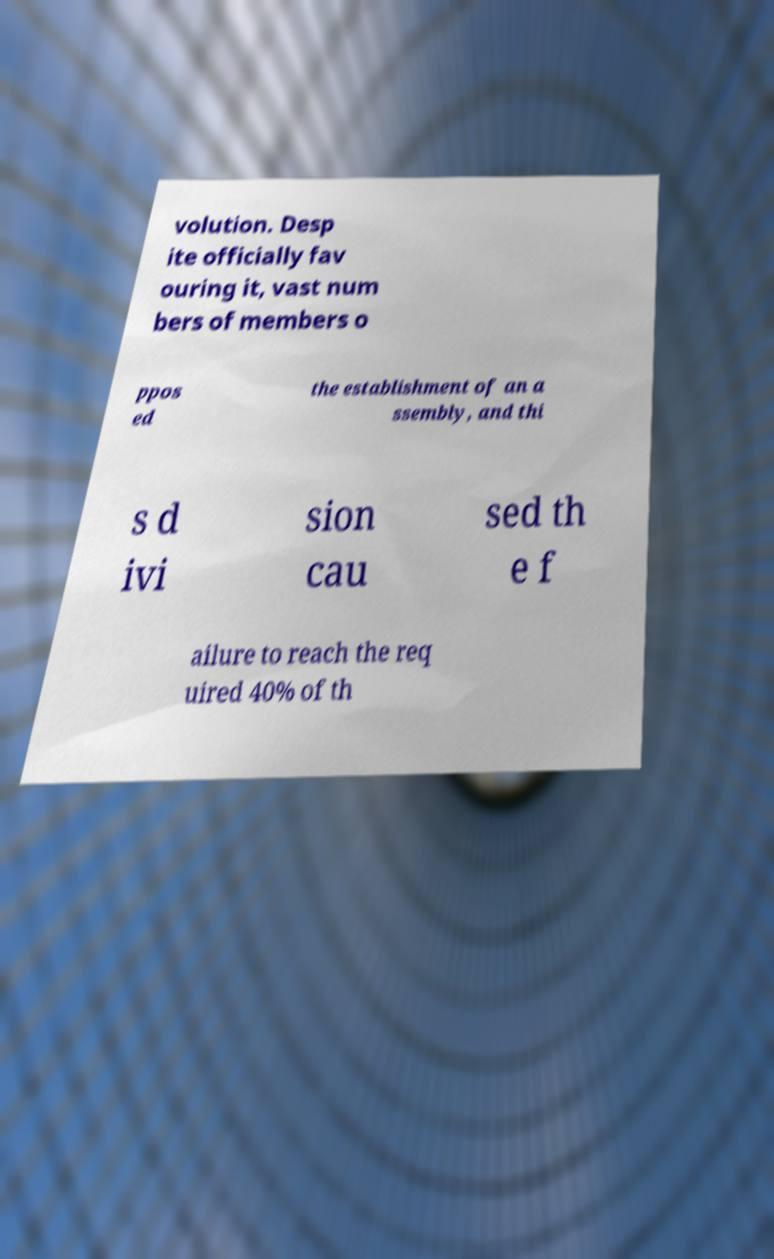Can you accurately transcribe the text from the provided image for me? volution. Desp ite officially fav ouring it, vast num bers of members o ppos ed the establishment of an a ssembly, and thi s d ivi sion cau sed th e f ailure to reach the req uired 40% of th 